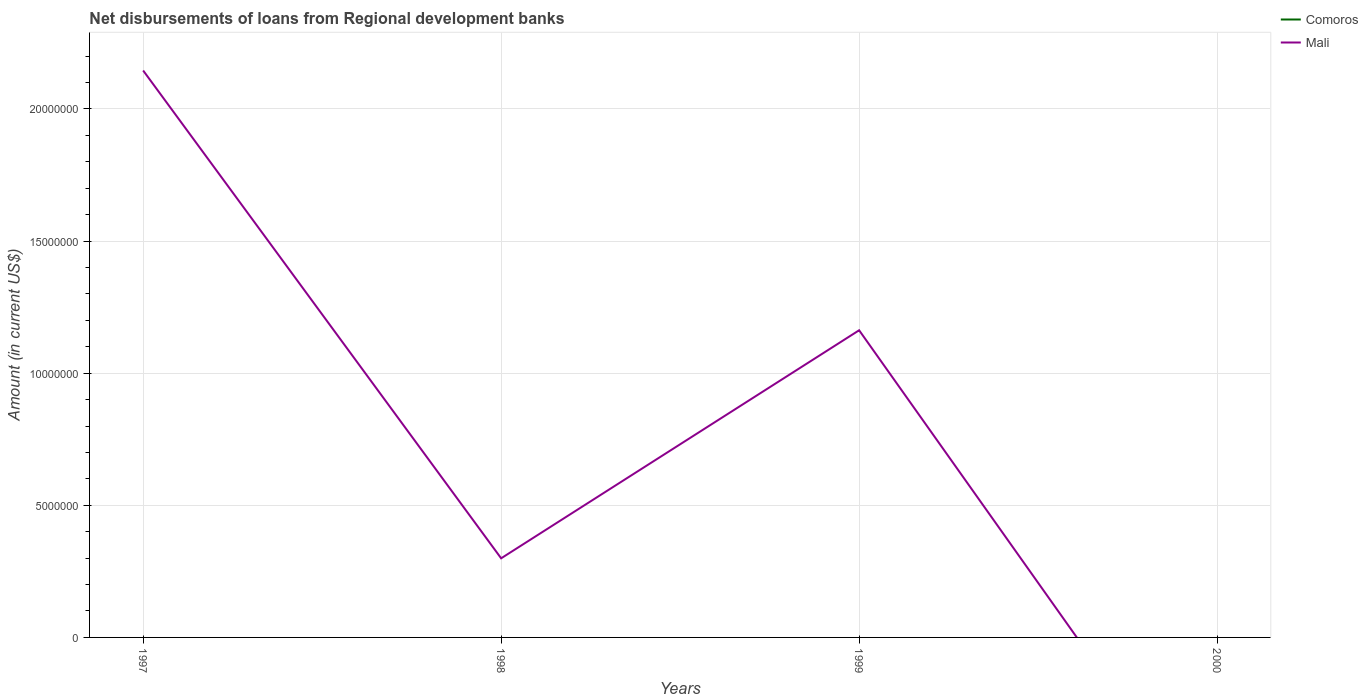Does the line corresponding to Comoros intersect with the line corresponding to Mali?
Your response must be concise. Yes. Across all years, what is the maximum amount of disbursements of loans from regional development banks in Mali?
Ensure brevity in your answer.  0. What is the total amount of disbursements of loans from regional development banks in Mali in the graph?
Make the answer very short. 9.83e+06. What is the difference between the highest and the second highest amount of disbursements of loans from regional development banks in Mali?
Keep it short and to the point. 2.15e+07. What is the difference between the highest and the lowest amount of disbursements of loans from regional development banks in Comoros?
Make the answer very short. 0. Is the amount of disbursements of loans from regional development banks in Mali strictly greater than the amount of disbursements of loans from regional development banks in Comoros over the years?
Your answer should be compact. No. How many lines are there?
Offer a terse response. 1. How many years are there in the graph?
Give a very brief answer. 4. What is the difference between two consecutive major ticks on the Y-axis?
Your answer should be very brief. 5.00e+06. Does the graph contain any zero values?
Provide a succinct answer. Yes. Where does the legend appear in the graph?
Your answer should be compact. Top right. How are the legend labels stacked?
Keep it short and to the point. Vertical. What is the title of the graph?
Provide a succinct answer. Net disbursements of loans from Regional development banks. Does "Vietnam" appear as one of the legend labels in the graph?
Your response must be concise. No. What is the label or title of the X-axis?
Keep it short and to the point. Years. What is the label or title of the Y-axis?
Provide a short and direct response. Amount (in current US$). What is the Amount (in current US$) of Comoros in 1997?
Keep it short and to the point. 0. What is the Amount (in current US$) of Mali in 1997?
Keep it short and to the point. 2.15e+07. What is the Amount (in current US$) of Mali in 1998?
Your answer should be very brief. 2.99e+06. What is the Amount (in current US$) in Comoros in 1999?
Provide a short and direct response. 0. What is the Amount (in current US$) in Mali in 1999?
Give a very brief answer. 1.16e+07. What is the Amount (in current US$) of Mali in 2000?
Your answer should be very brief. 0. Across all years, what is the maximum Amount (in current US$) in Mali?
Make the answer very short. 2.15e+07. What is the total Amount (in current US$) of Mali in the graph?
Provide a succinct answer. 3.61e+07. What is the difference between the Amount (in current US$) in Mali in 1997 and that in 1998?
Your response must be concise. 1.85e+07. What is the difference between the Amount (in current US$) in Mali in 1997 and that in 1999?
Your answer should be very brief. 9.83e+06. What is the difference between the Amount (in current US$) of Mali in 1998 and that in 1999?
Offer a terse response. -8.63e+06. What is the average Amount (in current US$) in Mali per year?
Make the answer very short. 9.02e+06. What is the ratio of the Amount (in current US$) of Mali in 1997 to that in 1998?
Your answer should be very brief. 7.17. What is the ratio of the Amount (in current US$) in Mali in 1997 to that in 1999?
Provide a succinct answer. 1.85. What is the ratio of the Amount (in current US$) of Mali in 1998 to that in 1999?
Ensure brevity in your answer.  0.26. What is the difference between the highest and the second highest Amount (in current US$) in Mali?
Offer a very short reply. 9.83e+06. What is the difference between the highest and the lowest Amount (in current US$) of Mali?
Offer a very short reply. 2.15e+07. 